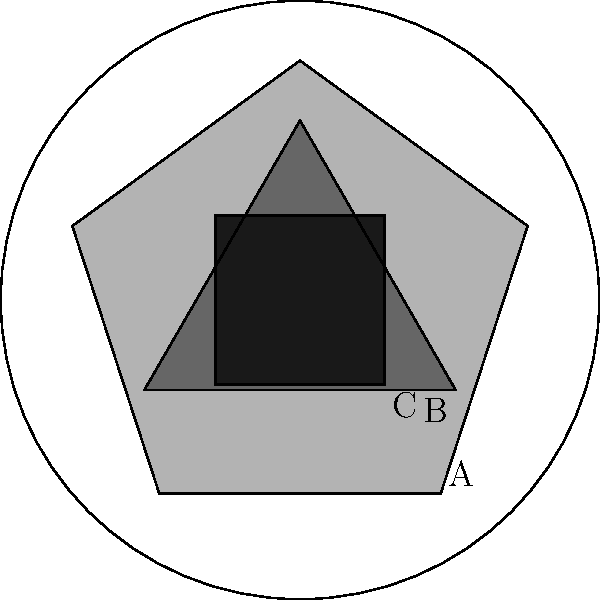In the tribal tattoo pattern shown above, which shape represents the most sacred symbol in our tradition? To answer this question, we need to analyze the tattoo pattern based on our tribal knowledge:

1. The outermost circle represents the boundary of the tattoo, symbolizing unity and completeness.

2. Inside, we see three distinct shapes:
   A. A pentagon (5-sided shape)
   B. A triangle (3-sided shape)
   C. A square (4-sided shape)

3. In our tribal tradition, the number of sides in a shape often corresponds to its spiritual significance:
   - 3 sides represent the connection between earth, sky, and spirit
   - 4 sides symbolize the four cardinal directions
   - 5 sides are associated with the five elements of nature

4. The triangle (B) is the darkest and placed centrally, indicating its importance.

5. In our tribe's belief system, the triangle is the most sacred symbol as it represents the trinity of existence: birth, life, and death.

Therefore, based on its central position, darker shading, and symbolic meaning in our tradition, the triangle (B) represents the most sacred symbol.
Answer: B (triangle) 